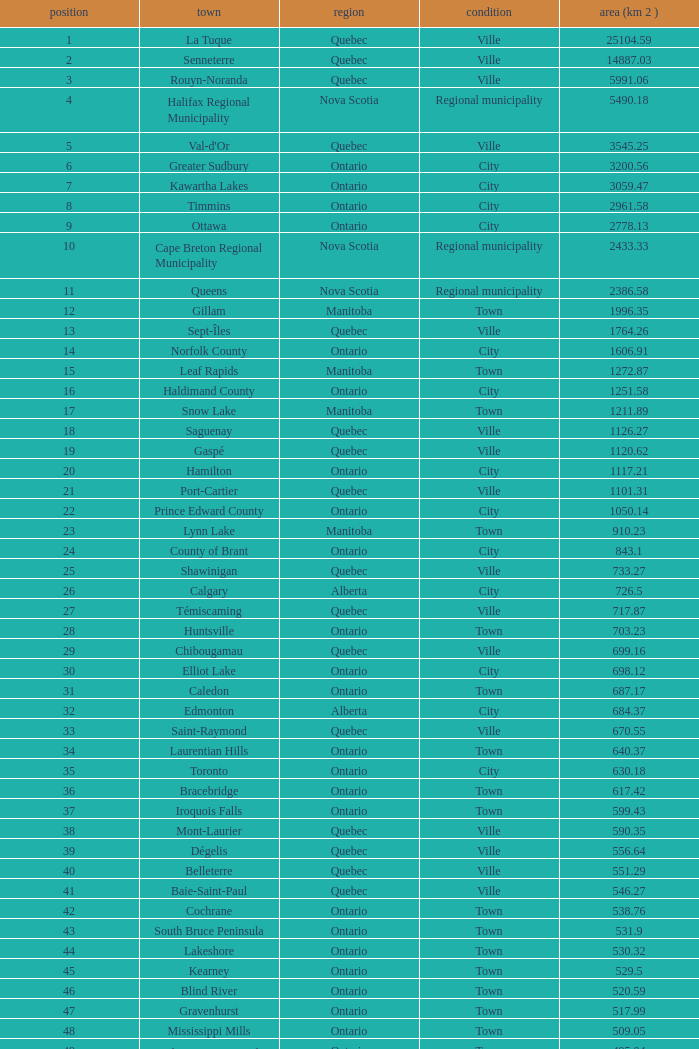What is the listed Status that has the Province of Ontario and Rank of 86? Town. Could you parse the entire table? {'header': ['position', 'town', 'region', 'condition', 'area (km 2 )'], 'rows': [['1', 'La Tuque', 'Quebec', 'Ville', '25104.59'], ['2', 'Senneterre', 'Quebec', 'Ville', '14887.03'], ['3', 'Rouyn-Noranda', 'Quebec', 'Ville', '5991.06'], ['4', 'Halifax Regional Municipality', 'Nova Scotia', 'Regional municipality', '5490.18'], ['5', "Val-d'Or", 'Quebec', 'Ville', '3545.25'], ['6', 'Greater Sudbury', 'Ontario', 'City', '3200.56'], ['7', 'Kawartha Lakes', 'Ontario', 'City', '3059.47'], ['8', 'Timmins', 'Ontario', 'City', '2961.58'], ['9', 'Ottawa', 'Ontario', 'City', '2778.13'], ['10', 'Cape Breton Regional Municipality', 'Nova Scotia', 'Regional municipality', '2433.33'], ['11', 'Queens', 'Nova Scotia', 'Regional municipality', '2386.58'], ['12', 'Gillam', 'Manitoba', 'Town', '1996.35'], ['13', 'Sept-Îles', 'Quebec', 'Ville', '1764.26'], ['14', 'Norfolk County', 'Ontario', 'City', '1606.91'], ['15', 'Leaf Rapids', 'Manitoba', 'Town', '1272.87'], ['16', 'Haldimand County', 'Ontario', 'City', '1251.58'], ['17', 'Snow Lake', 'Manitoba', 'Town', '1211.89'], ['18', 'Saguenay', 'Quebec', 'Ville', '1126.27'], ['19', 'Gaspé', 'Quebec', 'Ville', '1120.62'], ['20', 'Hamilton', 'Ontario', 'City', '1117.21'], ['21', 'Port-Cartier', 'Quebec', 'Ville', '1101.31'], ['22', 'Prince Edward County', 'Ontario', 'City', '1050.14'], ['23', 'Lynn Lake', 'Manitoba', 'Town', '910.23'], ['24', 'County of Brant', 'Ontario', 'City', '843.1'], ['25', 'Shawinigan', 'Quebec', 'Ville', '733.27'], ['26', 'Calgary', 'Alberta', 'City', '726.5'], ['27', 'Témiscaming', 'Quebec', 'Ville', '717.87'], ['28', 'Huntsville', 'Ontario', 'Town', '703.23'], ['29', 'Chibougamau', 'Quebec', 'Ville', '699.16'], ['30', 'Elliot Lake', 'Ontario', 'City', '698.12'], ['31', 'Caledon', 'Ontario', 'Town', '687.17'], ['32', 'Edmonton', 'Alberta', 'City', '684.37'], ['33', 'Saint-Raymond', 'Quebec', 'Ville', '670.55'], ['34', 'Laurentian Hills', 'Ontario', 'Town', '640.37'], ['35', 'Toronto', 'Ontario', 'City', '630.18'], ['36', 'Bracebridge', 'Ontario', 'Town', '617.42'], ['37', 'Iroquois Falls', 'Ontario', 'Town', '599.43'], ['38', 'Mont-Laurier', 'Quebec', 'Ville', '590.35'], ['39', 'Dégelis', 'Quebec', 'Ville', '556.64'], ['40', 'Belleterre', 'Quebec', 'Ville', '551.29'], ['41', 'Baie-Saint-Paul', 'Quebec', 'Ville', '546.27'], ['42', 'Cochrane', 'Ontario', 'Town', '538.76'], ['43', 'South Bruce Peninsula', 'Ontario', 'Town', '531.9'], ['44', 'Lakeshore', 'Ontario', 'Town', '530.32'], ['45', 'Kearney', 'Ontario', 'Town', '529.5'], ['46', 'Blind River', 'Ontario', 'Town', '520.59'], ['47', 'Gravenhurst', 'Ontario', 'Town', '517.99'], ['48', 'Mississippi Mills', 'Ontario', 'Town', '509.05'], ['49', 'Northeastern Manitoulin and the Islands', 'Ontario', 'Town', '495.04'], ['50', 'Quinte West', 'Ontario', 'City', '493.85'], ['51', 'Mirabel', 'Quebec', 'Ville', '485.51'], ['52', 'Fermont', 'Quebec', 'Ville', '470.67'], ['53', 'Winnipeg', 'Manitoba', 'City', '464.01'], ['54', 'Greater Napanee', 'Ontario', 'Town', '459.71'], ['55', 'La Malbaie', 'Quebec', 'Ville', '459.34'], ['56', 'Rivière-Rouge', 'Quebec', 'Ville', '454.99'], ['57', 'Québec City', 'Quebec', 'Ville', '454.26'], ['58', 'Kingston', 'Ontario', 'City', '450.39'], ['59', 'Lévis', 'Quebec', 'Ville', '449.32'], ['60', "St. John's", 'Newfoundland and Labrador', 'City', '446.04'], ['61', 'Bécancour', 'Quebec', 'Ville', '441'], ['62', 'Percé', 'Quebec', 'Ville', '432.39'], ['63', 'Amos', 'Quebec', 'Ville', '430.06'], ['64', 'London', 'Ontario', 'City', '420.57'], ['65', 'Chandler', 'Quebec', 'Ville', '419.5'], ['66', 'Whitehorse', 'Yukon', 'City', '416.43'], ['67', 'Gracefield', 'Quebec', 'Ville', '386.21'], ['68', 'Baie Verte', 'Newfoundland and Labrador', 'Town', '371.07'], ['69', 'Milton', 'Ontario', 'Town', '366.61'], ['70', 'Montreal', 'Quebec', 'Ville', '365.13'], ['71', 'Saint-Félicien', 'Quebec', 'Ville', '363.57'], ['72', 'Abbotsford', 'British Columbia', 'City', '359.36'], ['73', 'Sherbrooke', 'Quebec', 'Ville', '353.46'], ['74', 'Gatineau', 'Quebec', 'Ville', '342.32'], ['75', 'Pohénégamook', 'Quebec', 'Ville', '340.33'], ['76', 'Baie-Comeau', 'Quebec', 'Ville', '338.88'], ['77', 'Thunder Bay', 'Ontario', 'City', '328.48'], ['78', 'Plympton–Wyoming', 'Ontario', 'Town', '318.76'], ['79', 'Surrey', 'British Columbia', 'City', '317.19'], ['80', 'Prince George', 'British Columbia', 'City', '316'], ['81', 'Saint John', 'New Brunswick', 'City', '315.49'], ['82', 'North Bay', 'Ontario', 'City', '314.91'], ['83', 'Happy Valley-Goose Bay', 'Newfoundland and Labrador', 'Town', '305.85'], ['84', 'Minto', 'Ontario', 'Town', '300.37'], ['85', 'Kamloops', 'British Columbia', 'City', '297.3'], ['86', 'Erin', 'Ontario', 'Town', '296.98'], ['87', 'Clarence-Rockland', 'Ontario', 'City', '296.53'], ['88', 'Cookshire-Eaton', 'Quebec', 'Ville', '295.93'], ['89', 'Dolbeau-Mistassini', 'Quebec', 'Ville', '295.67'], ['90', 'Trois-Rivières', 'Quebec', 'Ville', '288.92'], ['91', 'Mississauga', 'Ontario', 'City', '288.53'], ['92', 'Georgina', 'Ontario', 'Town', '287.72'], ['93', 'The Blue Mountains', 'Ontario', 'Town', '286.78'], ['94', 'Innisfil', 'Ontario', 'Town', '284.18'], ['95', 'Essex', 'Ontario', 'Town', '277.95'], ['96', 'Mono', 'Ontario', 'Town', '277.67'], ['97', 'Halton Hills', 'Ontario', 'Town', '276.26'], ['98', 'New Tecumseth', 'Ontario', 'Town', '274.18'], ['99', 'Vaughan', 'Ontario', 'City', '273.58'], ['100', 'Brampton', 'Ontario', 'City', '266.71']]} 